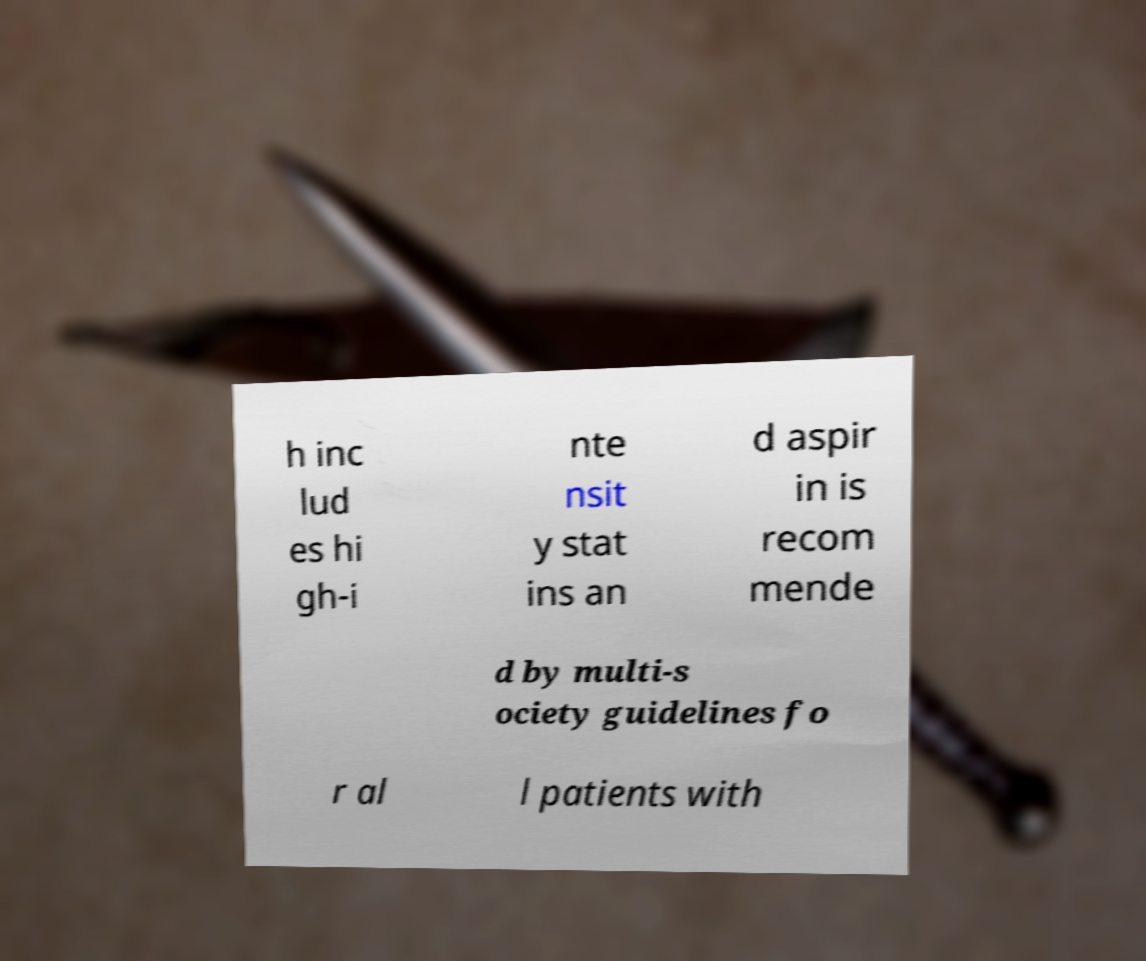I need the written content from this picture converted into text. Can you do that? h inc lud es hi gh-i nte nsit y stat ins an d aspir in is recom mende d by multi-s ociety guidelines fo r al l patients with 